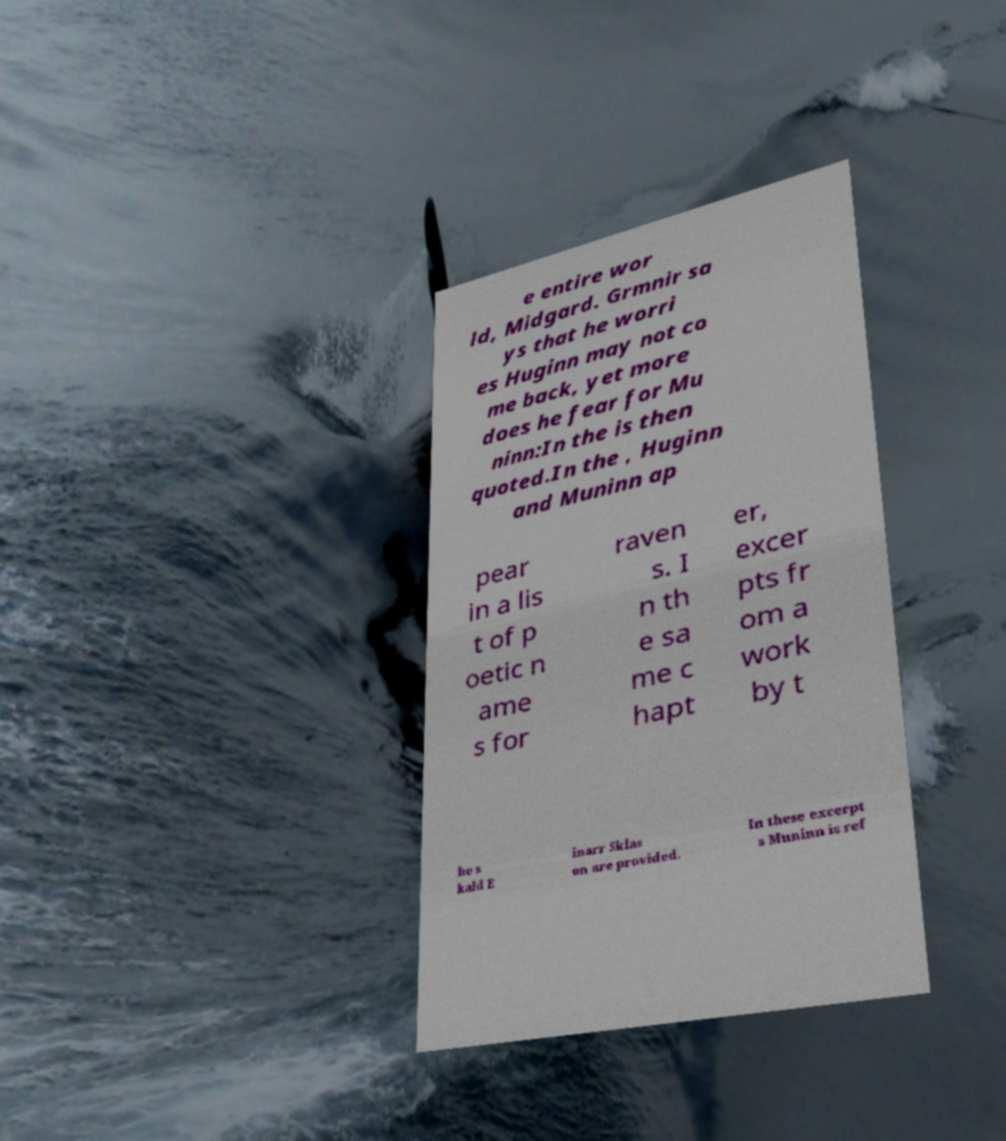Can you read and provide the text displayed in the image?This photo seems to have some interesting text. Can you extract and type it out for me? e entire wor ld, Midgard. Grmnir sa ys that he worri es Huginn may not co me back, yet more does he fear for Mu ninn:In the is then quoted.In the , Huginn and Muninn ap pear in a lis t of p oetic n ame s for raven s. I n th e sa me c hapt er, excer pts fr om a work by t he s kald E inarr Sklas on are provided. In these excerpt s Muninn is ref 